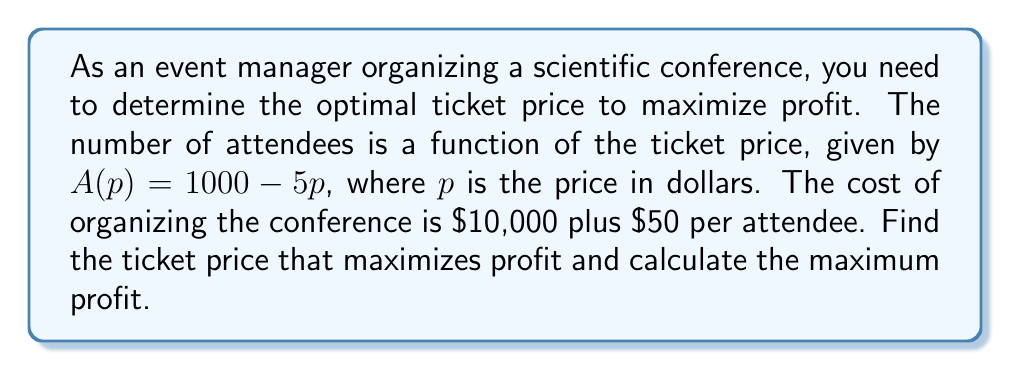Help me with this question. Let's approach this step-by-step:

1) First, let's define our profit function. Profit is revenue minus cost.

   Revenue = Price × Number of attendees
   $R(p) = p \cdot A(p) = p(1000 - 5p) = 1000p - 5p^2$

   Cost = Fixed cost + Variable cost per attendee × Number of attendees
   $C(p) = 10000 + 50(1000 - 5p) = 60000 - 250p$

   Profit = Revenue - Cost
   $P(p) = R(p) - C(p) = (1000p - 5p^2) - (60000 - 250p)$
   $P(p) = -5p^2 + 1250p - 60000$

2) To find the maximum profit, we need to find where the derivative of the profit function equals zero:

   $\frac{dP}{dp} = -10p + 1250 = 0$

3) Solve this equation:

   $-10p + 1250 = 0$
   $-10p = -1250$
   $p = 125$

4) To confirm this is a maximum, we can check the second derivative:

   $\frac{d^2P}{dp^2} = -10$, which is negative, confirming a maximum.

5) Therefore, the optimal price is $\$125$ per ticket.

6) To find the maximum profit, we substitute this price back into our profit function:

   $P(125) = -5(125)^2 + 1250(125) - 60000$
   $= -78125 + 156250 - 60000$
   $= 18125$

Thus, the maximum profit is $\$18,125$.
Answer: The optimal ticket price is $\$125$, and the maximum profit is $\$18,125$. 